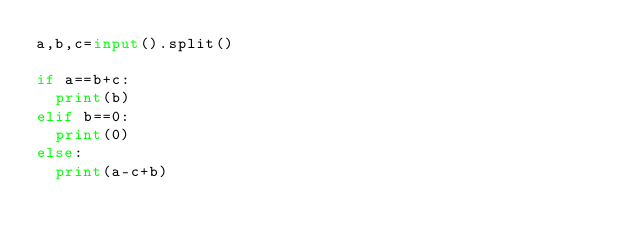<code> <loc_0><loc_0><loc_500><loc_500><_Python_>a,b,c=input().split()

if a==b+c:
  print(b)
elif b==0:
  print(0)
else:
  print(a-c+b)</code> 